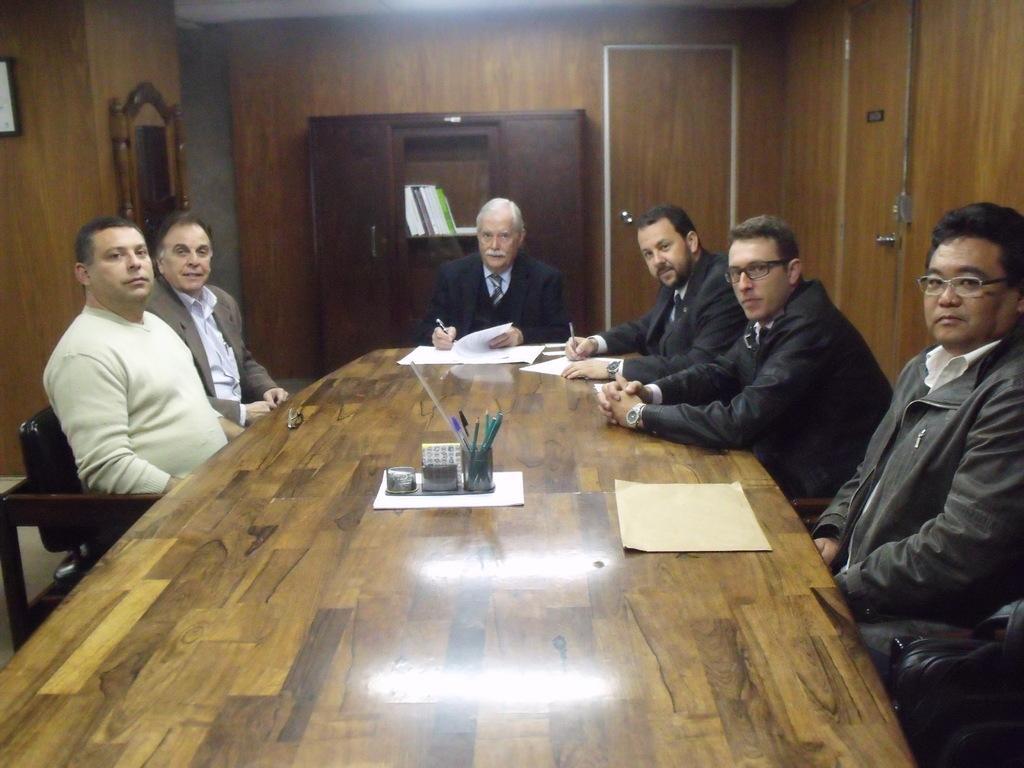Can you describe this image briefly? This is the picture inside the room. There are pens, papers on the table. At the back there is cupboard, there are books in the cupboard and the left side there is a mirror. There are people sitting around the table. 